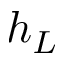<formula> <loc_0><loc_0><loc_500><loc_500>h _ { L }</formula> 